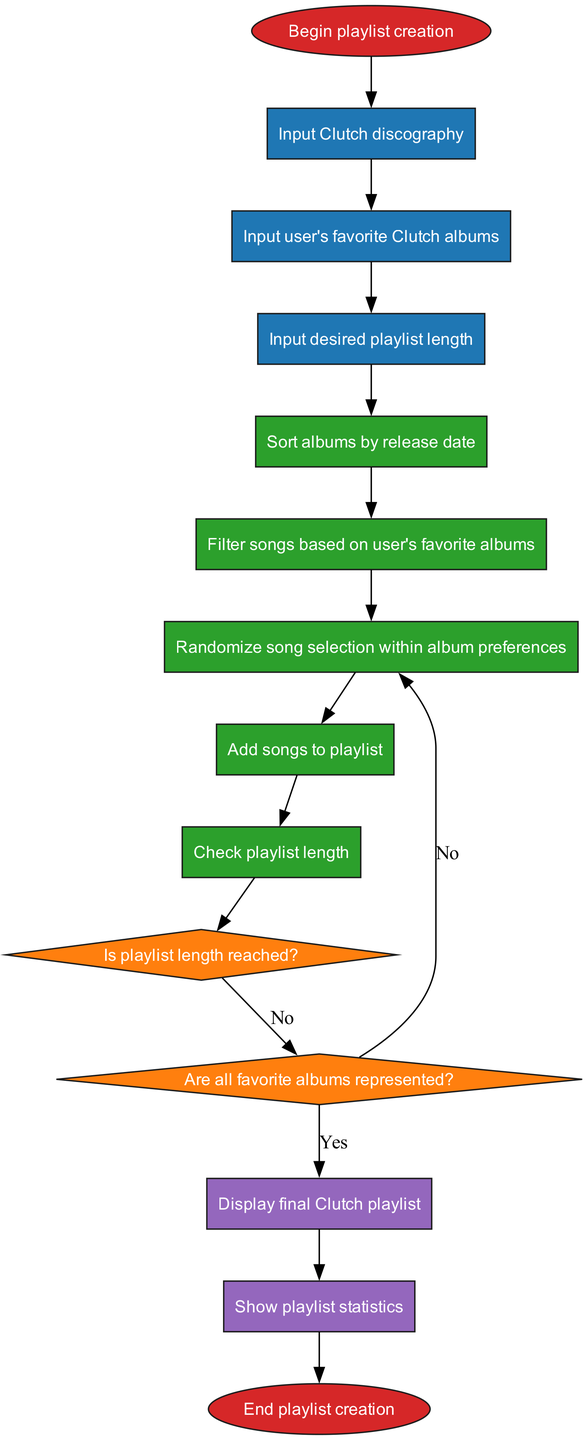What is the first input node in the flowchart? The first input node is labeled "Input Clutch discography". It is connected to the "start" node, indicating it is the first step after beginning the playlist creation process.
Answer: Input Clutch discography How many processes are there in the flowchart? There are five processes listed in the diagram that describe the steps taken to create the playlist, which are sequentially connected after the input nodes.
Answer: 5 What happens if the playlist length is not reached? If the playlist length is not reached after checking, the flow returns to process "Randomize song selection within album preferences", allowing for more songs to be added until the limit is met.
Answer: Add songs to playlist What are the outputs of the process? The outputs specified in the flowchart are "Display final Clutch playlist" and "Show playlist statistics", indicating the two results from the playlist creation process.
Answer: Display final Clutch playlist, Show playlist statistics In which process is the decision about the playlist length made? The decision regarding whether the playlist length is reached takes place after the last process, which is "Check playlist length". This leads to checking if the criteria are fulfilled or not.
Answer: Check playlist length What is the shape of the decision nodes in the flowchart? The decision nodes are represented as diamonds in the flowchart, indicating points where yes/no or true/false decisions are made about the playlist creation process.
Answer: Diamond How many input nodes are there in the flowchart? There are three input nodes total, reflecting the user's requirements for creating their Clutch playlist based on preferences and album data provided at the start.
Answer: 3 What determines if all favorite albums are represented? The check for whether all favorite albums are represented happens after the playlist length decision; if not, it loops back to the random song selection process to ensure all favorites are included.
Answer: Are all favorite albums represented? What color represents the process nodes in the diagram? The process nodes are colored green, visually differentiating them from input and decision nodes to illustrate various stages in the playlist creation workflow.
Answer: Green 